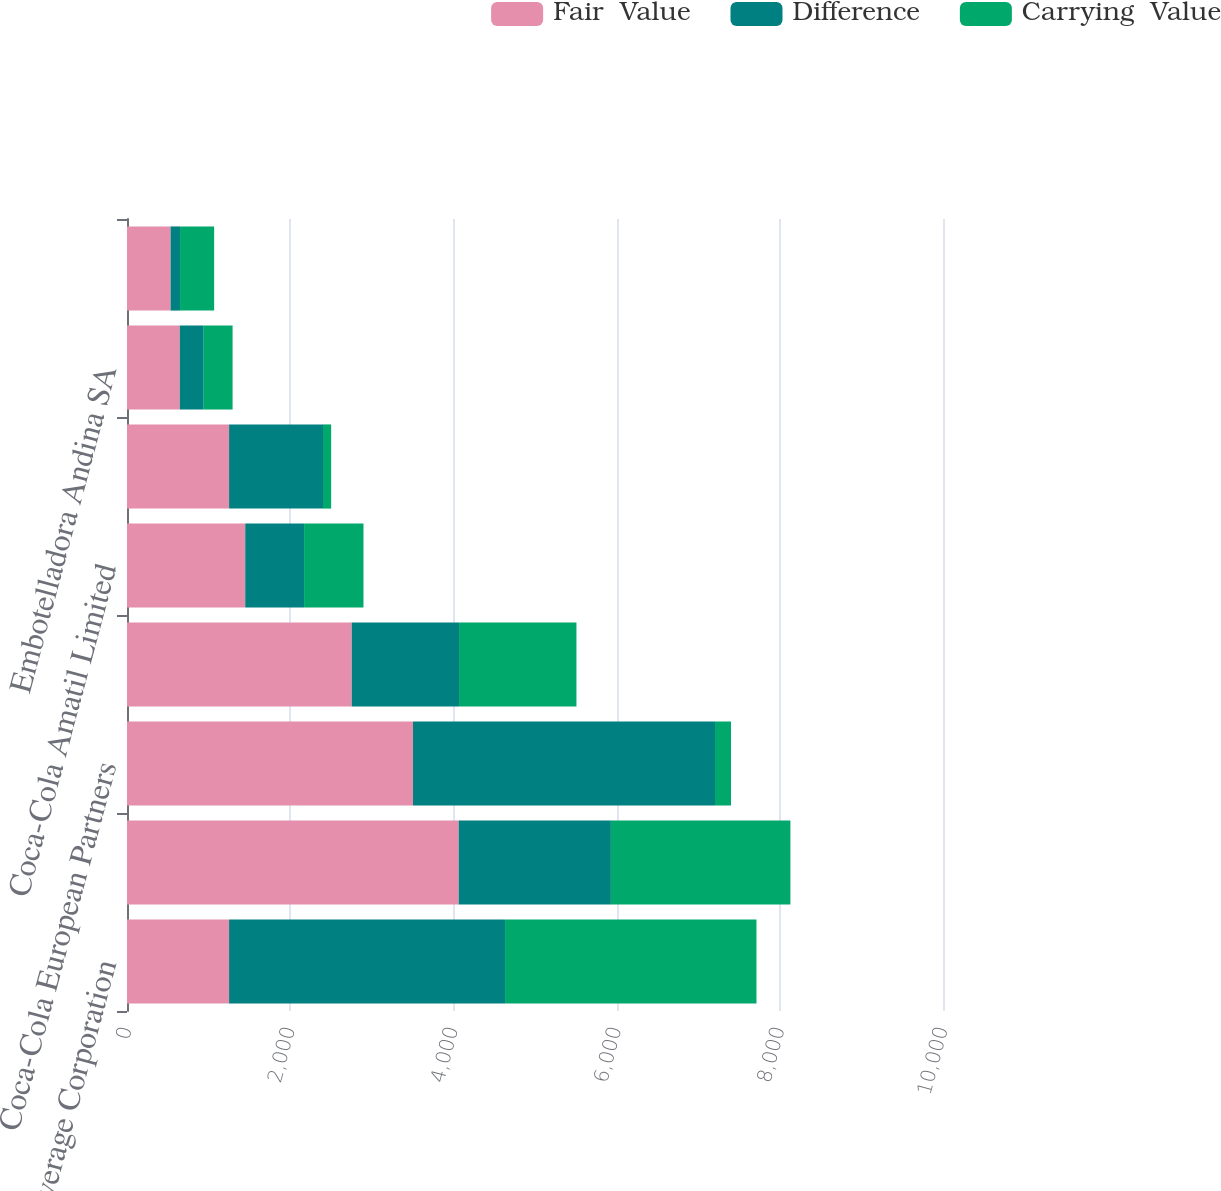<chart> <loc_0><loc_0><loc_500><loc_500><stacked_bar_chart><ecel><fcel>Monster Beverage Corporation<fcel>Coca-Cola FEMSA SAB de CV<fcel>Coca-Cola European Partners<fcel>Coca-Cola HBC AG<fcel>Coca-Cola Amatil Limited<fcel>Coca-Cola Bottlers Japan Inc<fcel>Embotelladora Andina SA<fcel>Coca-Cola Bottling Co<nl><fcel>Fair  Value<fcel>1251<fcel>4065<fcel>3505<fcel>2754<fcel>1449<fcel>1251<fcel>647<fcel>534<nl><fcel>Difference<fcel>3382<fcel>1865<fcel>3701<fcel>1315<fcel>721<fcel>1151<fcel>293<fcel>116<nl><fcel>Carrying  Value<fcel>3081<fcel>2200<fcel>196<fcel>1439<fcel>728<fcel>100<fcel>354<fcel>418<nl></chart> 